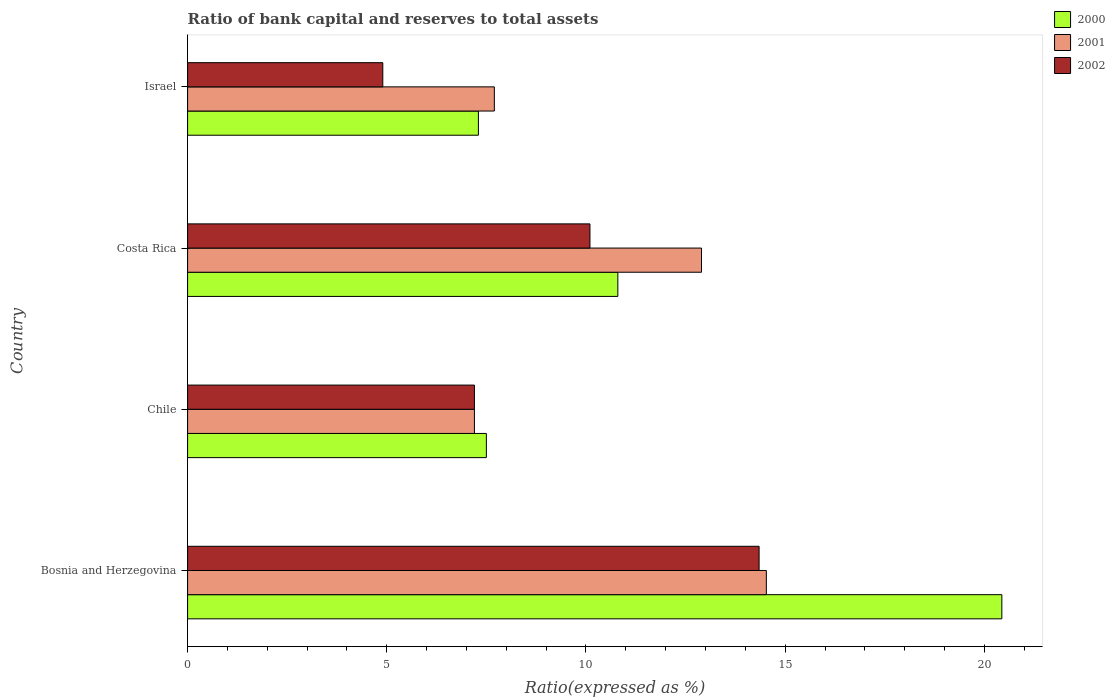Are the number of bars per tick equal to the number of legend labels?
Give a very brief answer. Yes. How many bars are there on the 4th tick from the top?
Offer a terse response. 3. What is the label of the 3rd group of bars from the top?
Keep it short and to the point. Chile. In how many cases, is the number of bars for a given country not equal to the number of legend labels?
Ensure brevity in your answer.  0. What is the ratio of bank capital and reserves to total assets in 2001 in Bosnia and Herzegovina?
Provide a short and direct response. 14.53. Across all countries, what is the maximum ratio of bank capital and reserves to total assets in 2001?
Offer a very short reply. 14.53. In which country was the ratio of bank capital and reserves to total assets in 2001 maximum?
Ensure brevity in your answer.  Bosnia and Herzegovina. What is the total ratio of bank capital and reserves to total assets in 2002 in the graph?
Your response must be concise. 36.55. What is the difference between the ratio of bank capital and reserves to total assets in 2001 in Chile and that in Costa Rica?
Offer a terse response. -5.7. What is the difference between the ratio of bank capital and reserves to total assets in 2002 in Israel and the ratio of bank capital and reserves to total assets in 2000 in Costa Rica?
Your answer should be very brief. -5.9. What is the average ratio of bank capital and reserves to total assets in 2002 per country?
Give a very brief answer. 9.14. What is the difference between the ratio of bank capital and reserves to total assets in 2000 and ratio of bank capital and reserves to total assets in 2001 in Israel?
Make the answer very short. -0.4. What is the ratio of the ratio of bank capital and reserves to total assets in 2002 in Bosnia and Herzegovina to that in Costa Rica?
Your answer should be very brief. 1.42. Is the difference between the ratio of bank capital and reserves to total assets in 2000 in Costa Rica and Israel greater than the difference between the ratio of bank capital and reserves to total assets in 2001 in Costa Rica and Israel?
Your answer should be compact. No. What is the difference between the highest and the second highest ratio of bank capital and reserves to total assets in 2000?
Your answer should be compact. 9.64. What is the difference between the highest and the lowest ratio of bank capital and reserves to total assets in 2001?
Offer a terse response. 7.33. Is the sum of the ratio of bank capital and reserves to total assets in 2001 in Bosnia and Herzegovina and Chile greater than the maximum ratio of bank capital and reserves to total assets in 2000 across all countries?
Give a very brief answer. Yes. Is it the case that in every country, the sum of the ratio of bank capital and reserves to total assets in 2001 and ratio of bank capital and reserves to total assets in 2002 is greater than the ratio of bank capital and reserves to total assets in 2000?
Provide a short and direct response. Yes. How many bars are there?
Give a very brief answer. 12. Are all the bars in the graph horizontal?
Your answer should be very brief. Yes. Does the graph contain any zero values?
Offer a very short reply. No. Where does the legend appear in the graph?
Provide a succinct answer. Top right. What is the title of the graph?
Provide a short and direct response. Ratio of bank capital and reserves to total assets. What is the label or title of the X-axis?
Offer a terse response. Ratio(expressed as %). What is the label or title of the Y-axis?
Your answer should be compact. Country. What is the Ratio(expressed as %) of 2000 in Bosnia and Herzegovina?
Provide a short and direct response. 20.44. What is the Ratio(expressed as %) of 2001 in Bosnia and Herzegovina?
Your answer should be very brief. 14.53. What is the Ratio(expressed as %) in 2002 in Bosnia and Herzegovina?
Offer a very short reply. 14.35. What is the Ratio(expressed as %) of 2001 in Chile?
Your answer should be compact. 7.2. What is the Ratio(expressed as %) of 2001 in Costa Rica?
Provide a short and direct response. 12.9. Across all countries, what is the maximum Ratio(expressed as %) of 2000?
Your answer should be very brief. 20.44. Across all countries, what is the maximum Ratio(expressed as %) of 2001?
Provide a short and direct response. 14.53. Across all countries, what is the maximum Ratio(expressed as %) in 2002?
Ensure brevity in your answer.  14.35. Across all countries, what is the minimum Ratio(expressed as %) of 2001?
Offer a very short reply. 7.2. What is the total Ratio(expressed as %) of 2000 in the graph?
Keep it short and to the point. 46.04. What is the total Ratio(expressed as %) in 2001 in the graph?
Offer a very short reply. 42.33. What is the total Ratio(expressed as %) in 2002 in the graph?
Provide a succinct answer. 36.55. What is the difference between the Ratio(expressed as %) in 2000 in Bosnia and Herzegovina and that in Chile?
Provide a succinct answer. 12.94. What is the difference between the Ratio(expressed as %) of 2001 in Bosnia and Herzegovina and that in Chile?
Keep it short and to the point. 7.33. What is the difference between the Ratio(expressed as %) in 2002 in Bosnia and Herzegovina and that in Chile?
Your response must be concise. 7.15. What is the difference between the Ratio(expressed as %) in 2000 in Bosnia and Herzegovina and that in Costa Rica?
Ensure brevity in your answer.  9.64. What is the difference between the Ratio(expressed as %) of 2001 in Bosnia and Herzegovina and that in Costa Rica?
Make the answer very short. 1.63. What is the difference between the Ratio(expressed as %) of 2002 in Bosnia and Herzegovina and that in Costa Rica?
Your answer should be very brief. 4.25. What is the difference between the Ratio(expressed as %) in 2000 in Bosnia and Herzegovina and that in Israel?
Ensure brevity in your answer.  13.14. What is the difference between the Ratio(expressed as %) of 2001 in Bosnia and Herzegovina and that in Israel?
Give a very brief answer. 6.83. What is the difference between the Ratio(expressed as %) in 2002 in Bosnia and Herzegovina and that in Israel?
Ensure brevity in your answer.  9.45. What is the difference between the Ratio(expressed as %) of 2000 in Chile and that in Costa Rica?
Provide a short and direct response. -3.3. What is the difference between the Ratio(expressed as %) in 2002 in Chile and that in Costa Rica?
Your response must be concise. -2.9. What is the difference between the Ratio(expressed as %) in 2002 in Chile and that in Israel?
Ensure brevity in your answer.  2.3. What is the difference between the Ratio(expressed as %) of 2000 in Bosnia and Herzegovina and the Ratio(expressed as %) of 2001 in Chile?
Your answer should be very brief. 13.24. What is the difference between the Ratio(expressed as %) in 2000 in Bosnia and Herzegovina and the Ratio(expressed as %) in 2002 in Chile?
Give a very brief answer. 13.24. What is the difference between the Ratio(expressed as %) in 2001 in Bosnia and Herzegovina and the Ratio(expressed as %) in 2002 in Chile?
Keep it short and to the point. 7.33. What is the difference between the Ratio(expressed as %) of 2000 in Bosnia and Herzegovina and the Ratio(expressed as %) of 2001 in Costa Rica?
Your response must be concise. 7.54. What is the difference between the Ratio(expressed as %) in 2000 in Bosnia and Herzegovina and the Ratio(expressed as %) in 2002 in Costa Rica?
Offer a very short reply. 10.34. What is the difference between the Ratio(expressed as %) in 2001 in Bosnia and Herzegovina and the Ratio(expressed as %) in 2002 in Costa Rica?
Offer a terse response. 4.43. What is the difference between the Ratio(expressed as %) in 2000 in Bosnia and Herzegovina and the Ratio(expressed as %) in 2001 in Israel?
Provide a short and direct response. 12.74. What is the difference between the Ratio(expressed as %) in 2000 in Bosnia and Herzegovina and the Ratio(expressed as %) in 2002 in Israel?
Offer a very short reply. 15.54. What is the difference between the Ratio(expressed as %) of 2001 in Bosnia and Herzegovina and the Ratio(expressed as %) of 2002 in Israel?
Your response must be concise. 9.63. What is the difference between the Ratio(expressed as %) in 2000 in Chile and the Ratio(expressed as %) in 2001 in Costa Rica?
Make the answer very short. -5.4. What is the difference between the Ratio(expressed as %) in 2000 in Chile and the Ratio(expressed as %) in 2002 in Israel?
Provide a short and direct response. 2.6. What is the difference between the Ratio(expressed as %) in 2001 in Chile and the Ratio(expressed as %) in 2002 in Israel?
Make the answer very short. 2.3. What is the difference between the Ratio(expressed as %) in 2000 in Costa Rica and the Ratio(expressed as %) in 2001 in Israel?
Keep it short and to the point. 3.1. What is the difference between the Ratio(expressed as %) of 2000 in Costa Rica and the Ratio(expressed as %) of 2002 in Israel?
Offer a terse response. 5.9. What is the average Ratio(expressed as %) in 2000 per country?
Offer a terse response. 11.51. What is the average Ratio(expressed as %) in 2001 per country?
Offer a very short reply. 10.58. What is the average Ratio(expressed as %) in 2002 per country?
Offer a terse response. 9.14. What is the difference between the Ratio(expressed as %) of 2000 and Ratio(expressed as %) of 2001 in Bosnia and Herzegovina?
Give a very brief answer. 5.91. What is the difference between the Ratio(expressed as %) of 2000 and Ratio(expressed as %) of 2002 in Bosnia and Herzegovina?
Provide a short and direct response. 6.09. What is the difference between the Ratio(expressed as %) of 2001 and Ratio(expressed as %) of 2002 in Bosnia and Herzegovina?
Provide a short and direct response. 0.18. What is the difference between the Ratio(expressed as %) in 2000 and Ratio(expressed as %) in 2001 in Costa Rica?
Give a very brief answer. -2.1. What is the difference between the Ratio(expressed as %) of 2001 and Ratio(expressed as %) of 2002 in Costa Rica?
Your answer should be very brief. 2.8. What is the difference between the Ratio(expressed as %) of 2001 and Ratio(expressed as %) of 2002 in Israel?
Provide a succinct answer. 2.8. What is the ratio of the Ratio(expressed as %) in 2000 in Bosnia and Herzegovina to that in Chile?
Give a very brief answer. 2.73. What is the ratio of the Ratio(expressed as %) in 2001 in Bosnia and Herzegovina to that in Chile?
Offer a terse response. 2.02. What is the ratio of the Ratio(expressed as %) in 2002 in Bosnia and Herzegovina to that in Chile?
Your response must be concise. 1.99. What is the ratio of the Ratio(expressed as %) of 2000 in Bosnia and Herzegovina to that in Costa Rica?
Provide a succinct answer. 1.89. What is the ratio of the Ratio(expressed as %) in 2001 in Bosnia and Herzegovina to that in Costa Rica?
Your answer should be compact. 1.13. What is the ratio of the Ratio(expressed as %) in 2002 in Bosnia and Herzegovina to that in Costa Rica?
Your answer should be very brief. 1.42. What is the ratio of the Ratio(expressed as %) of 2000 in Bosnia and Herzegovina to that in Israel?
Ensure brevity in your answer.  2.8. What is the ratio of the Ratio(expressed as %) of 2001 in Bosnia and Herzegovina to that in Israel?
Keep it short and to the point. 1.89. What is the ratio of the Ratio(expressed as %) in 2002 in Bosnia and Herzegovina to that in Israel?
Offer a terse response. 2.93. What is the ratio of the Ratio(expressed as %) in 2000 in Chile to that in Costa Rica?
Offer a terse response. 0.69. What is the ratio of the Ratio(expressed as %) in 2001 in Chile to that in Costa Rica?
Provide a short and direct response. 0.56. What is the ratio of the Ratio(expressed as %) of 2002 in Chile to that in Costa Rica?
Give a very brief answer. 0.71. What is the ratio of the Ratio(expressed as %) of 2000 in Chile to that in Israel?
Your response must be concise. 1.03. What is the ratio of the Ratio(expressed as %) of 2001 in Chile to that in Israel?
Provide a short and direct response. 0.94. What is the ratio of the Ratio(expressed as %) in 2002 in Chile to that in Israel?
Provide a succinct answer. 1.47. What is the ratio of the Ratio(expressed as %) in 2000 in Costa Rica to that in Israel?
Offer a terse response. 1.48. What is the ratio of the Ratio(expressed as %) of 2001 in Costa Rica to that in Israel?
Ensure brevity in your answer.  1.68. What is the ratio of the Ratio(expressed as %) in 2002 in Costa Rica to that in Israel?
Provide a short and direct response. 2.06. What is the difference between the highest and the second highest Ratio(expressed as %) of 2000?
Provide a short and direct response. 9.64. What is the difference between the highest and the second highest Ratio(expressed as %) of 2001?
Keep it short and to the point. 1.63. What is the difference between the highest and the second highest Ratio(expressed as %) of 2002?
Provide a short and direct response. 4.25. What is the difference between the highest and the lowest Ratio(expressed as %) of 2000?
Your answer should be compact. 13.14. What is the difference between the highest and the lowest Ratio(expressed as %) of 2001?
Keep it short and to the point. 7.33. What is the difference between the highest and the lowest Ratio(expressed as %) in 2002?
Offer a very short reply. 9.45. 